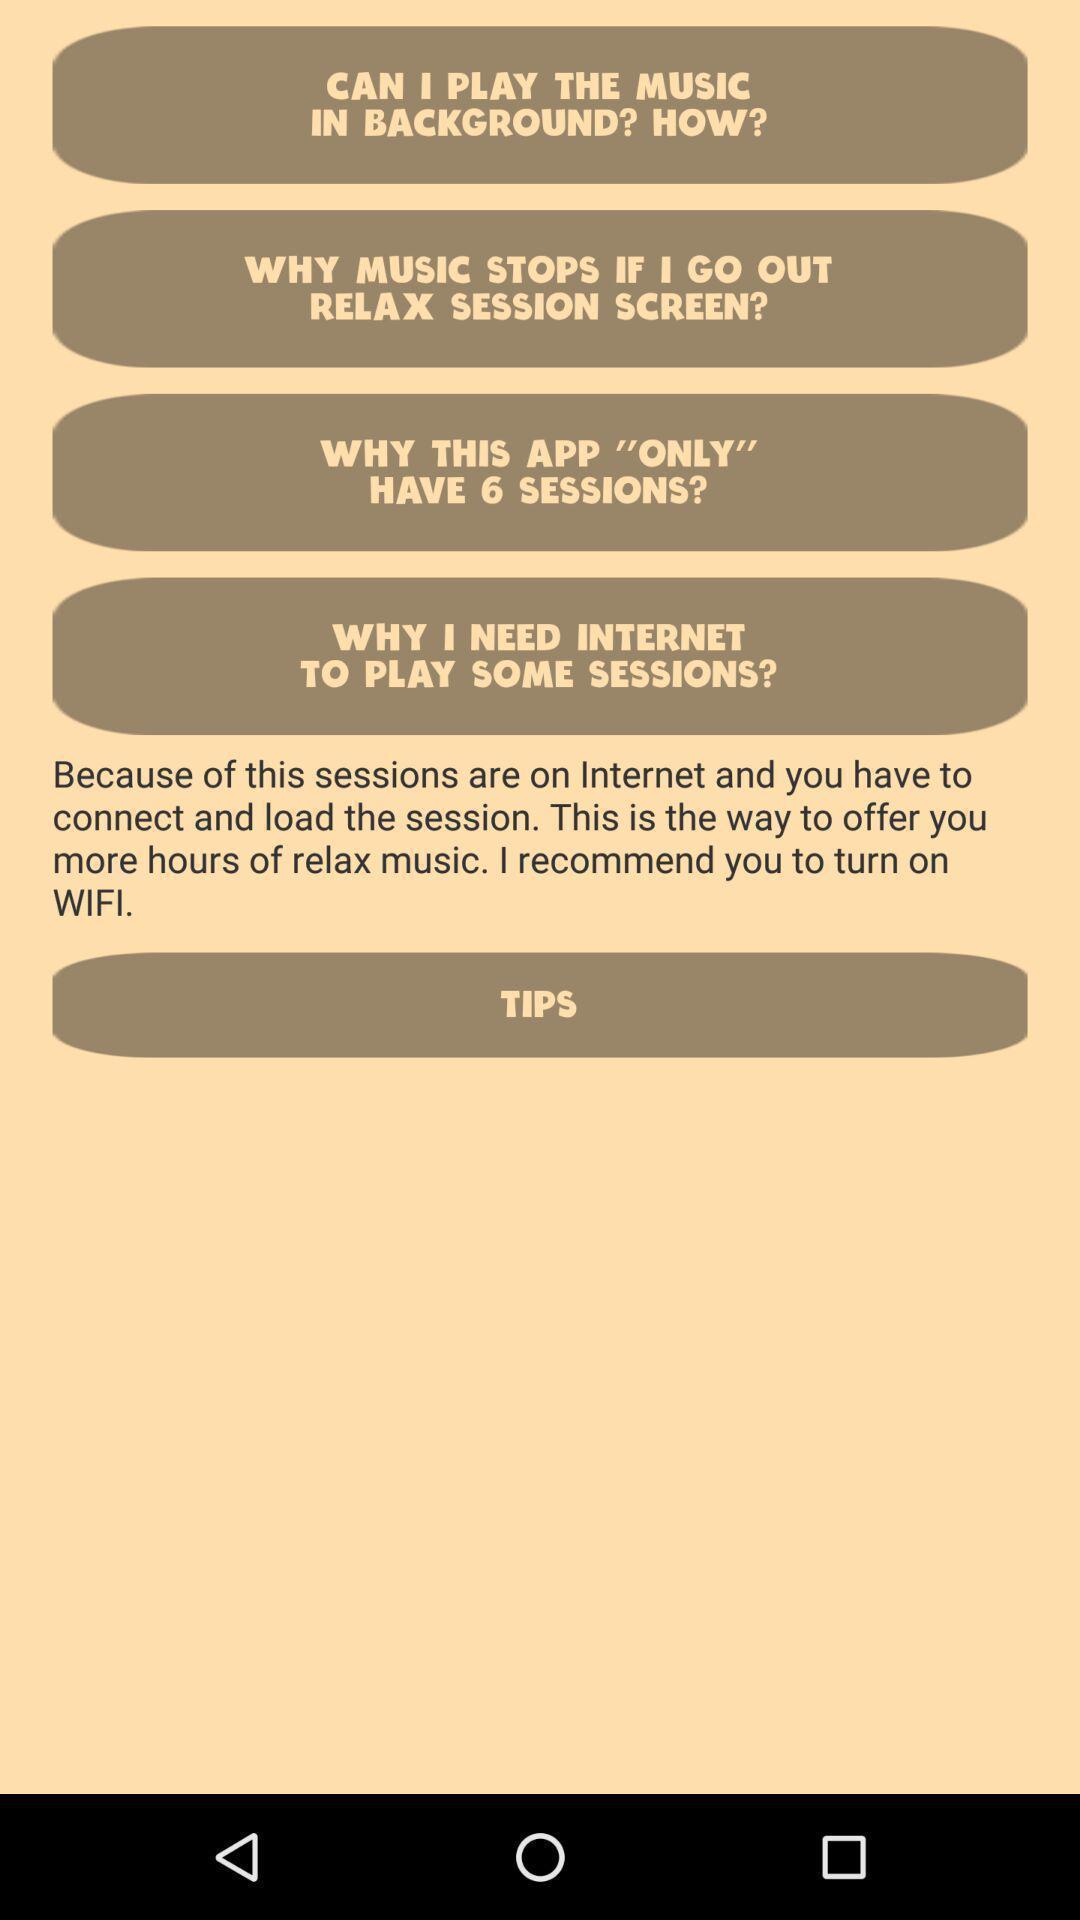Explain what's happening in this screen capture. Screen shows questions to play sessions. 